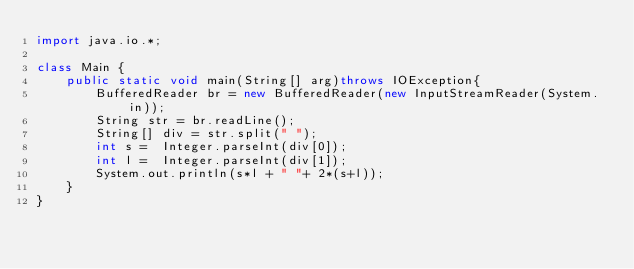Convert code to text. <code><loc_0><loc_0><loc_500><loc_500><_Java_>import java.io.*;
 
class Main {
    public static void main(String[] arg)throws IOException{
        BufferedReader br = new BufferedReader(new InputStreamReader(System.in));
        String str = br.readLine();
        String[] div = str.split(" ");
        int s =  Integer.parseInt(div[0]);
        int l =  Integer.parseInt(div[1]);
        System.out.println(s*l + " "+ 2*(s+l));
    }   
}</code> 